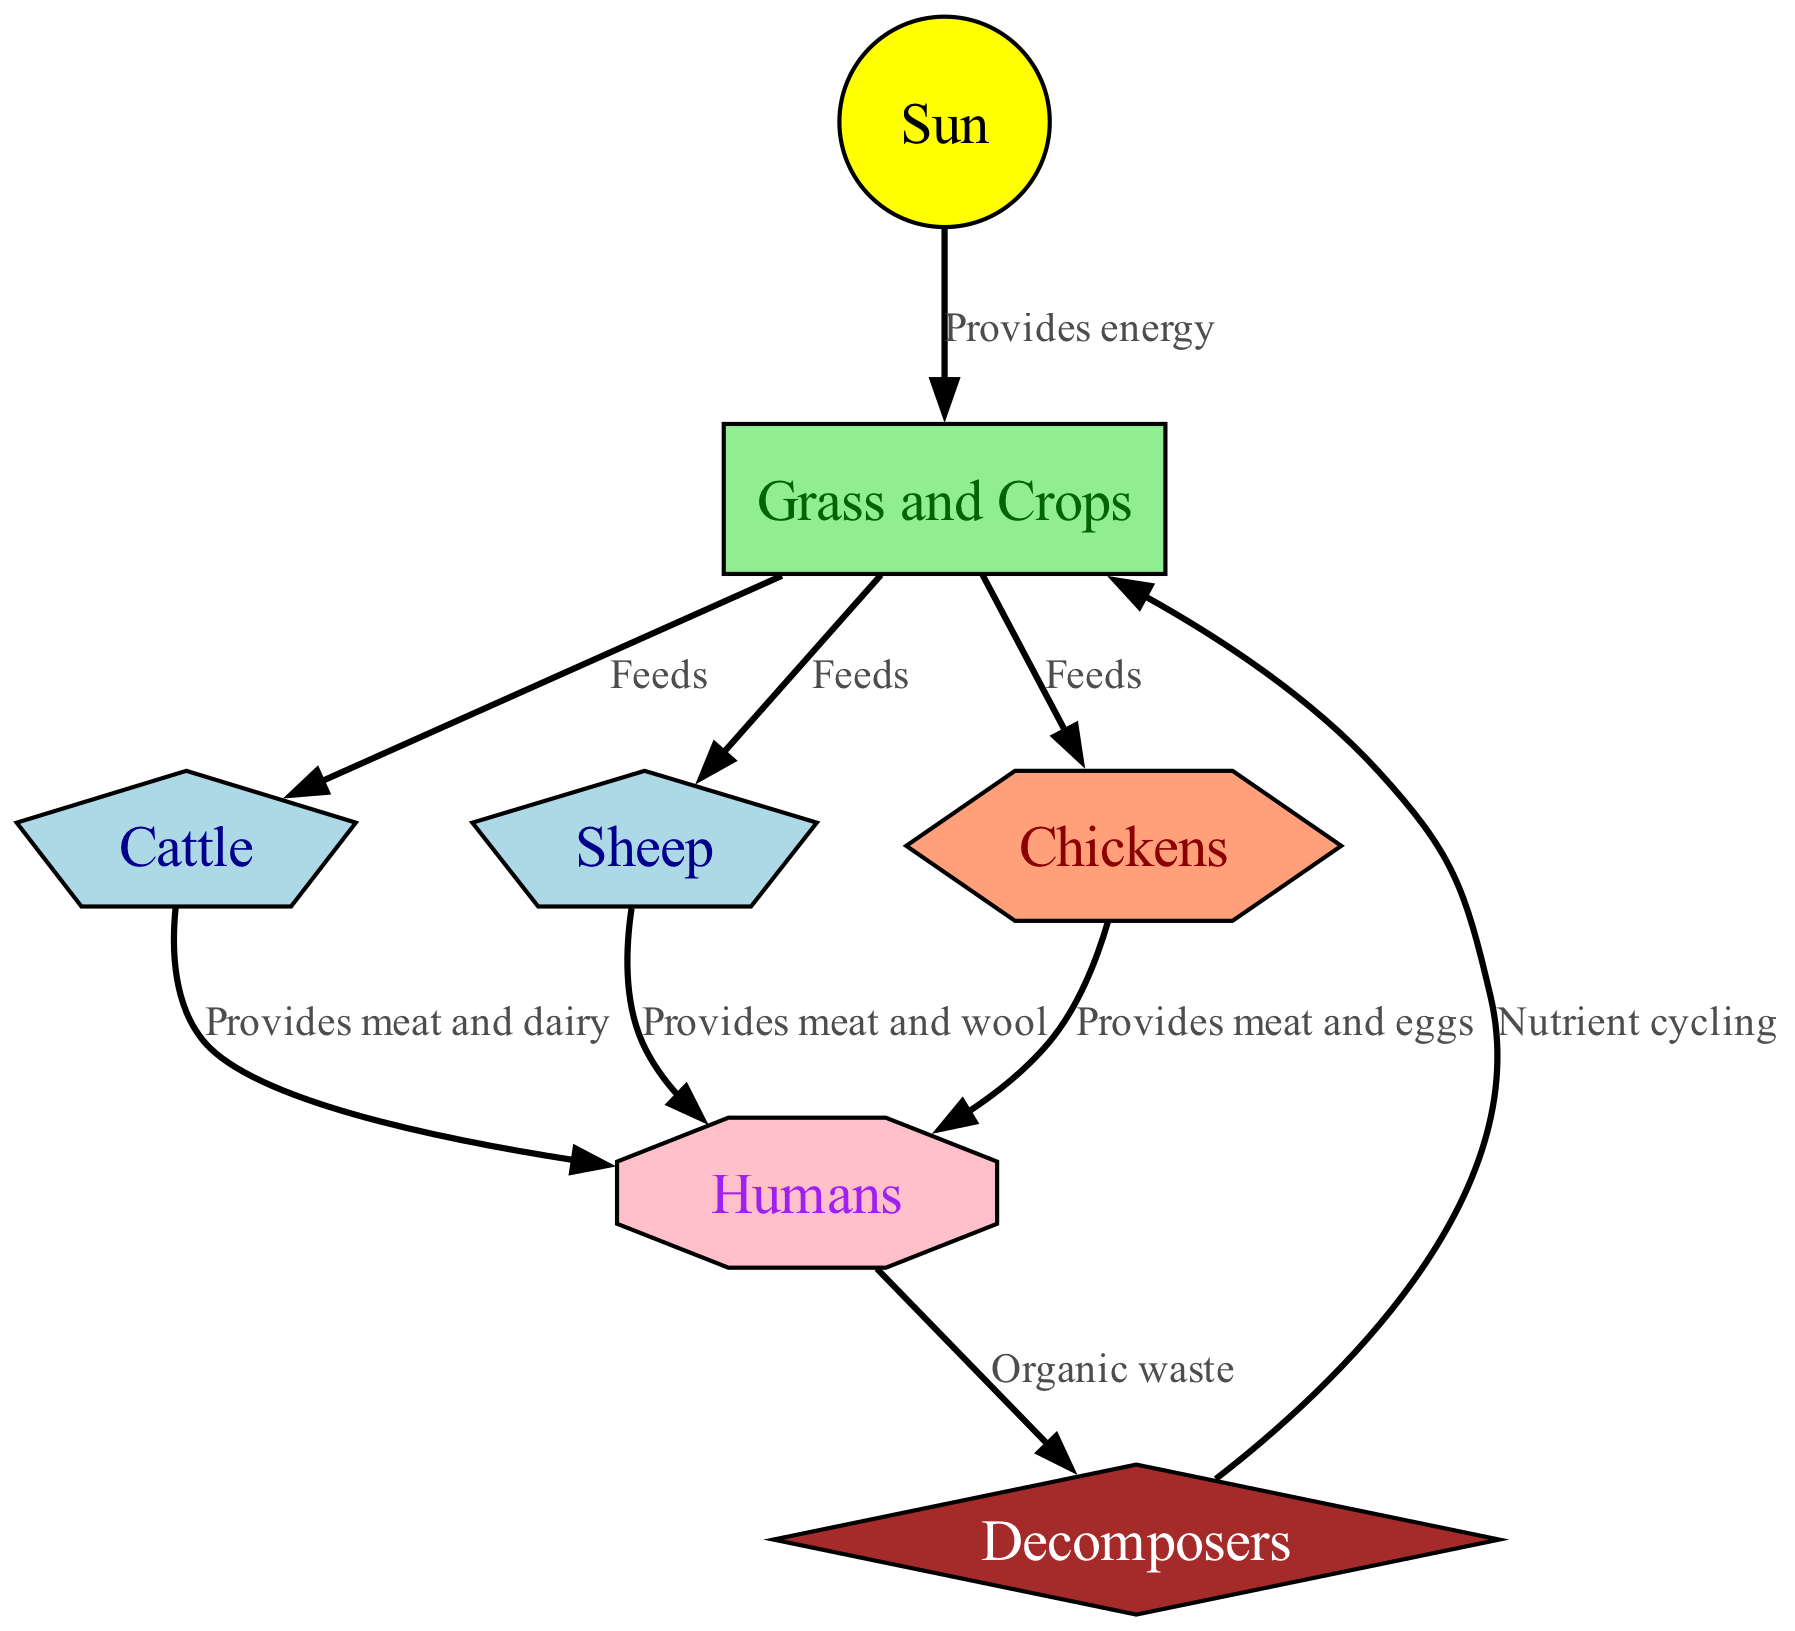What are the producers in this food chain? Producers are the organisms that create energy from sunlight through photosynthesis. In this diagram, "Grass and Crops" are identified as the only producers, as indicated in the node type.
Answer: Grass and Crops How many primary consumers are represented in the diagram? The primary consumers in the food chain are organisms that feed on the producers. In this diagram, both "Cattle" and "Sheep" are classified as primary consumers, totaling two.
Answer: 2 What does the Sun provide to the Grass and Crops? The relationship shows that the Sun provides energy to Grass and Crops. This is indicated by the label connecting these two nodes directly.
Answer: Provides energy Which organisms provide meat and eggs to humans? The diagram shows that "Chickens" are specifically mentioned to provide both meat and eggs to humans. This relationship is highlighted in the connections from Chickens to Humans.
Answer: Chickens What is the role of decomposers in this food chain? Decomposers are responsible for breaking down organic waste and returning nutrients to the soil. In this food chain, the relationship from Humans to Decomposers indicates their role in managing organic waste, which is essential for nutrient cycling back to the producers.
Answer: Nutrient cycling How many total relationships are there in the diagram? By counting each unique directional edge that connects the nodes, we find a total of nine relationships visually depicted in the diagram, each representing a specific interaction.
Answer: 9 Which primary consumer provides wool to humans? The diagram indicates that "Sheep" provide both meat and wool to humans, as shown in the direct labeling of the relationship between Sheep and Humans.
Answer: Sheep Which consumers are directly dependent on grass and crops? The relationships in the diagram clearly show that "Cattle," "Sheep," and "Chickens" all depend directly on Grass and Crops for their sustenance, as indicated by the edges connecting to these primary producers.
Answer: Cattle, Sheep, Chickens What is the significance of decomposers in relation to Grass and Crops? Decomposers help in nutrient cycling by breaking down organic waste produced by humans and returning nutrients back to the Grass and Crops, thus supporting their growth and sustainability in the food chain.
Answer: Nutrient cycling 